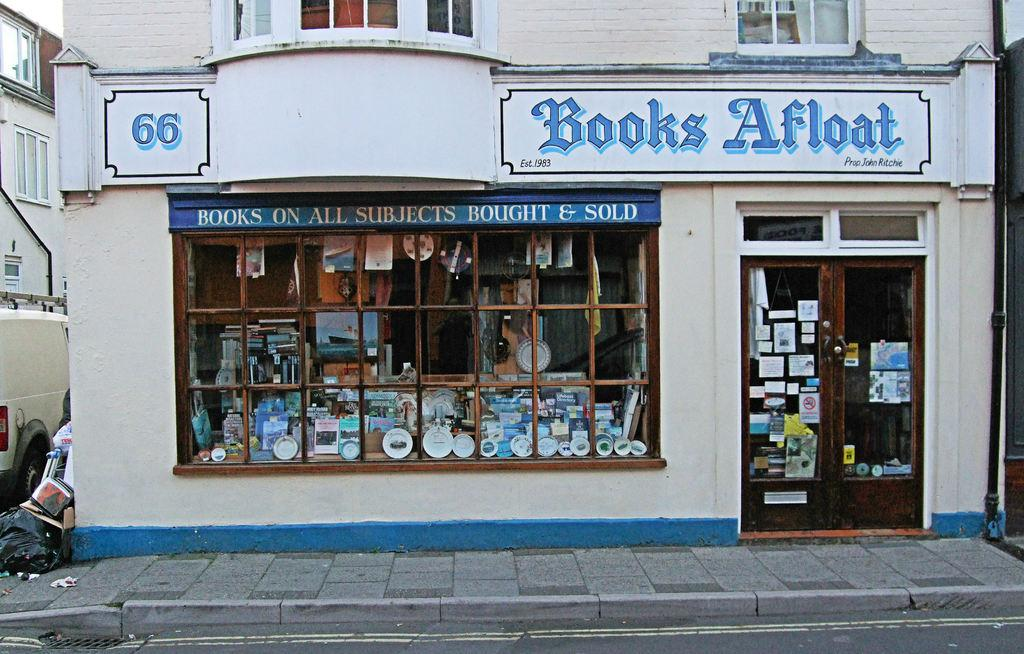<image>
Summarize the visual content of the image. A store front with the name Books Afloat on it. 